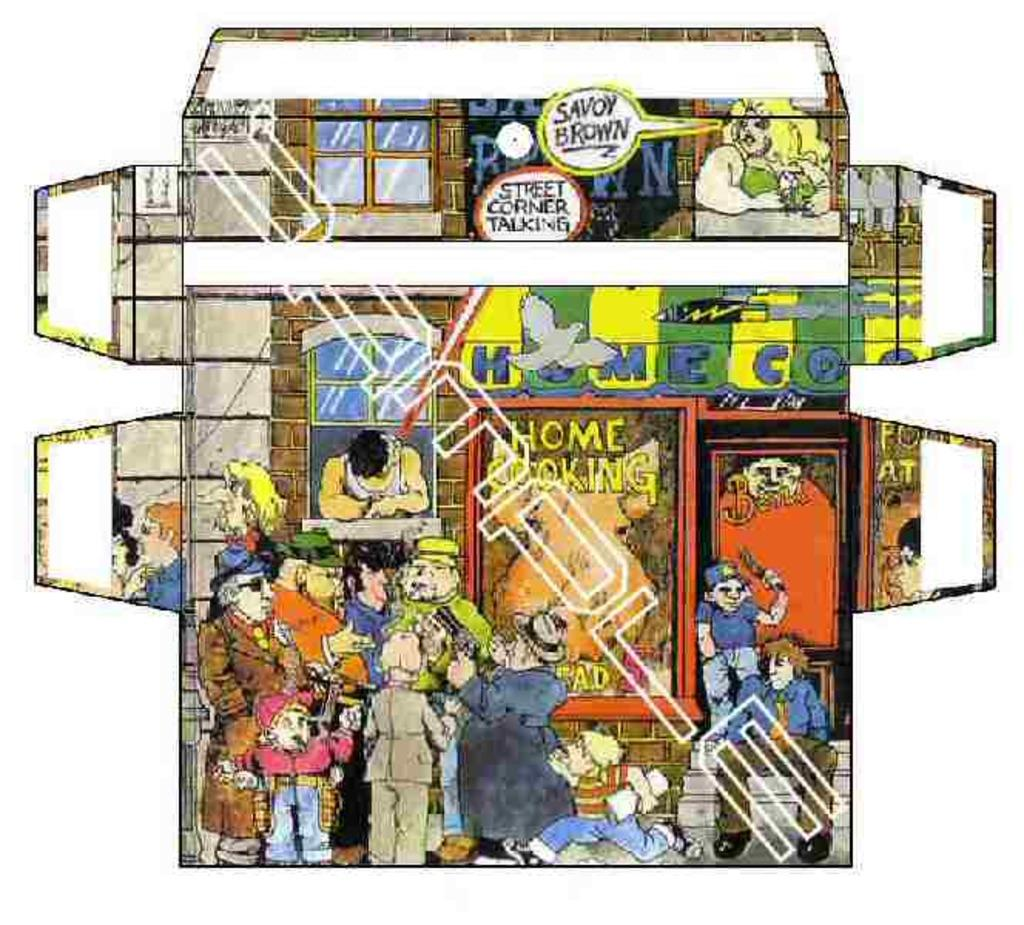What type of characters are present in the image? The image contains cartoons. What type of structure can be seen in the image? There is a house in the image. Where is the window located in the image? There is a window in the front of the image. Reasoning: Let' Let's think step by step in order to produce the conversation. We start by identifying the main subject of the image, which is cartoons. Then, we describe the main structure present in the image, which is a house. Finally, we focus on a specific detail of the house, which is the window located in the front. Each question is designed to elicit a specific detail about the image that is known from the provided facts. Absurd Question/Answer: What type of jail can be seen in the image? There is no jail present in the image; it contains cartoons and a house. What committee is responsible for the design of the house in the image? There is no information about a committee responsible for the design of the house in the image. 